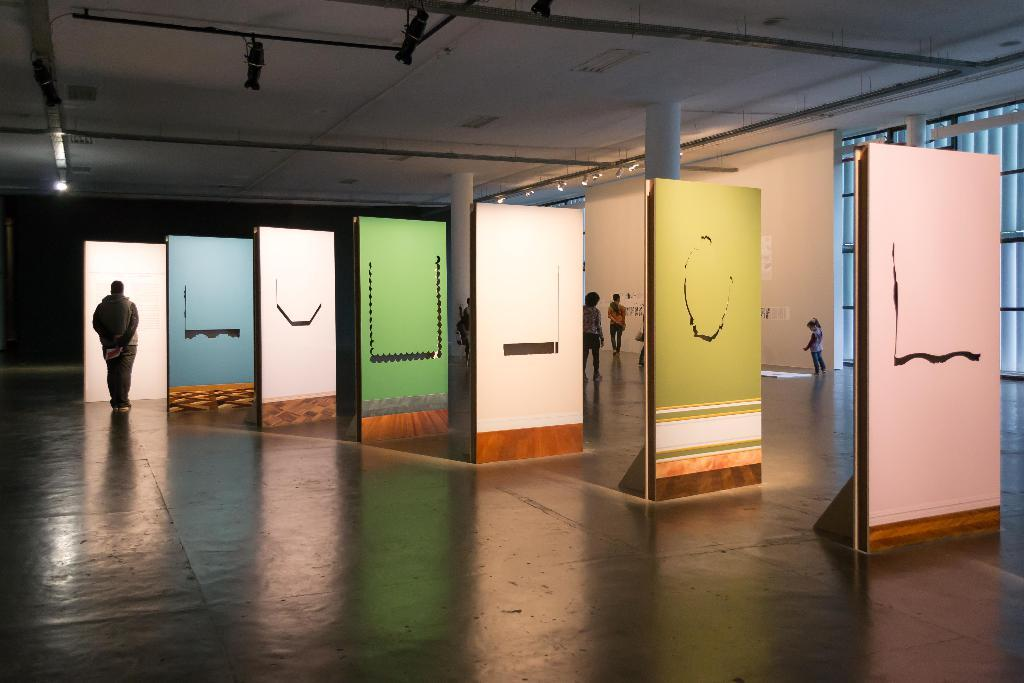What are the people in the image doing? The people in the image are on the floor. What can be seen illuminating the scene in the image? There are lights visible in the image. What is in the background of the image? There is a wall in the background of the image. What type of rod can be seen bending in the image? There is no rod present in the image, let alone one that is bending. 